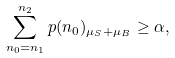<formula> <loc_0><loc_0><loc_500><loc_500>\sum _ { n _ { 0 } = n _ { 1 } } ^ { n _ { 2 } } p ( n _ { 0 } ) _ { \mu _ { S } + \mu _ { B } } \geq \alpha ,</formula> 